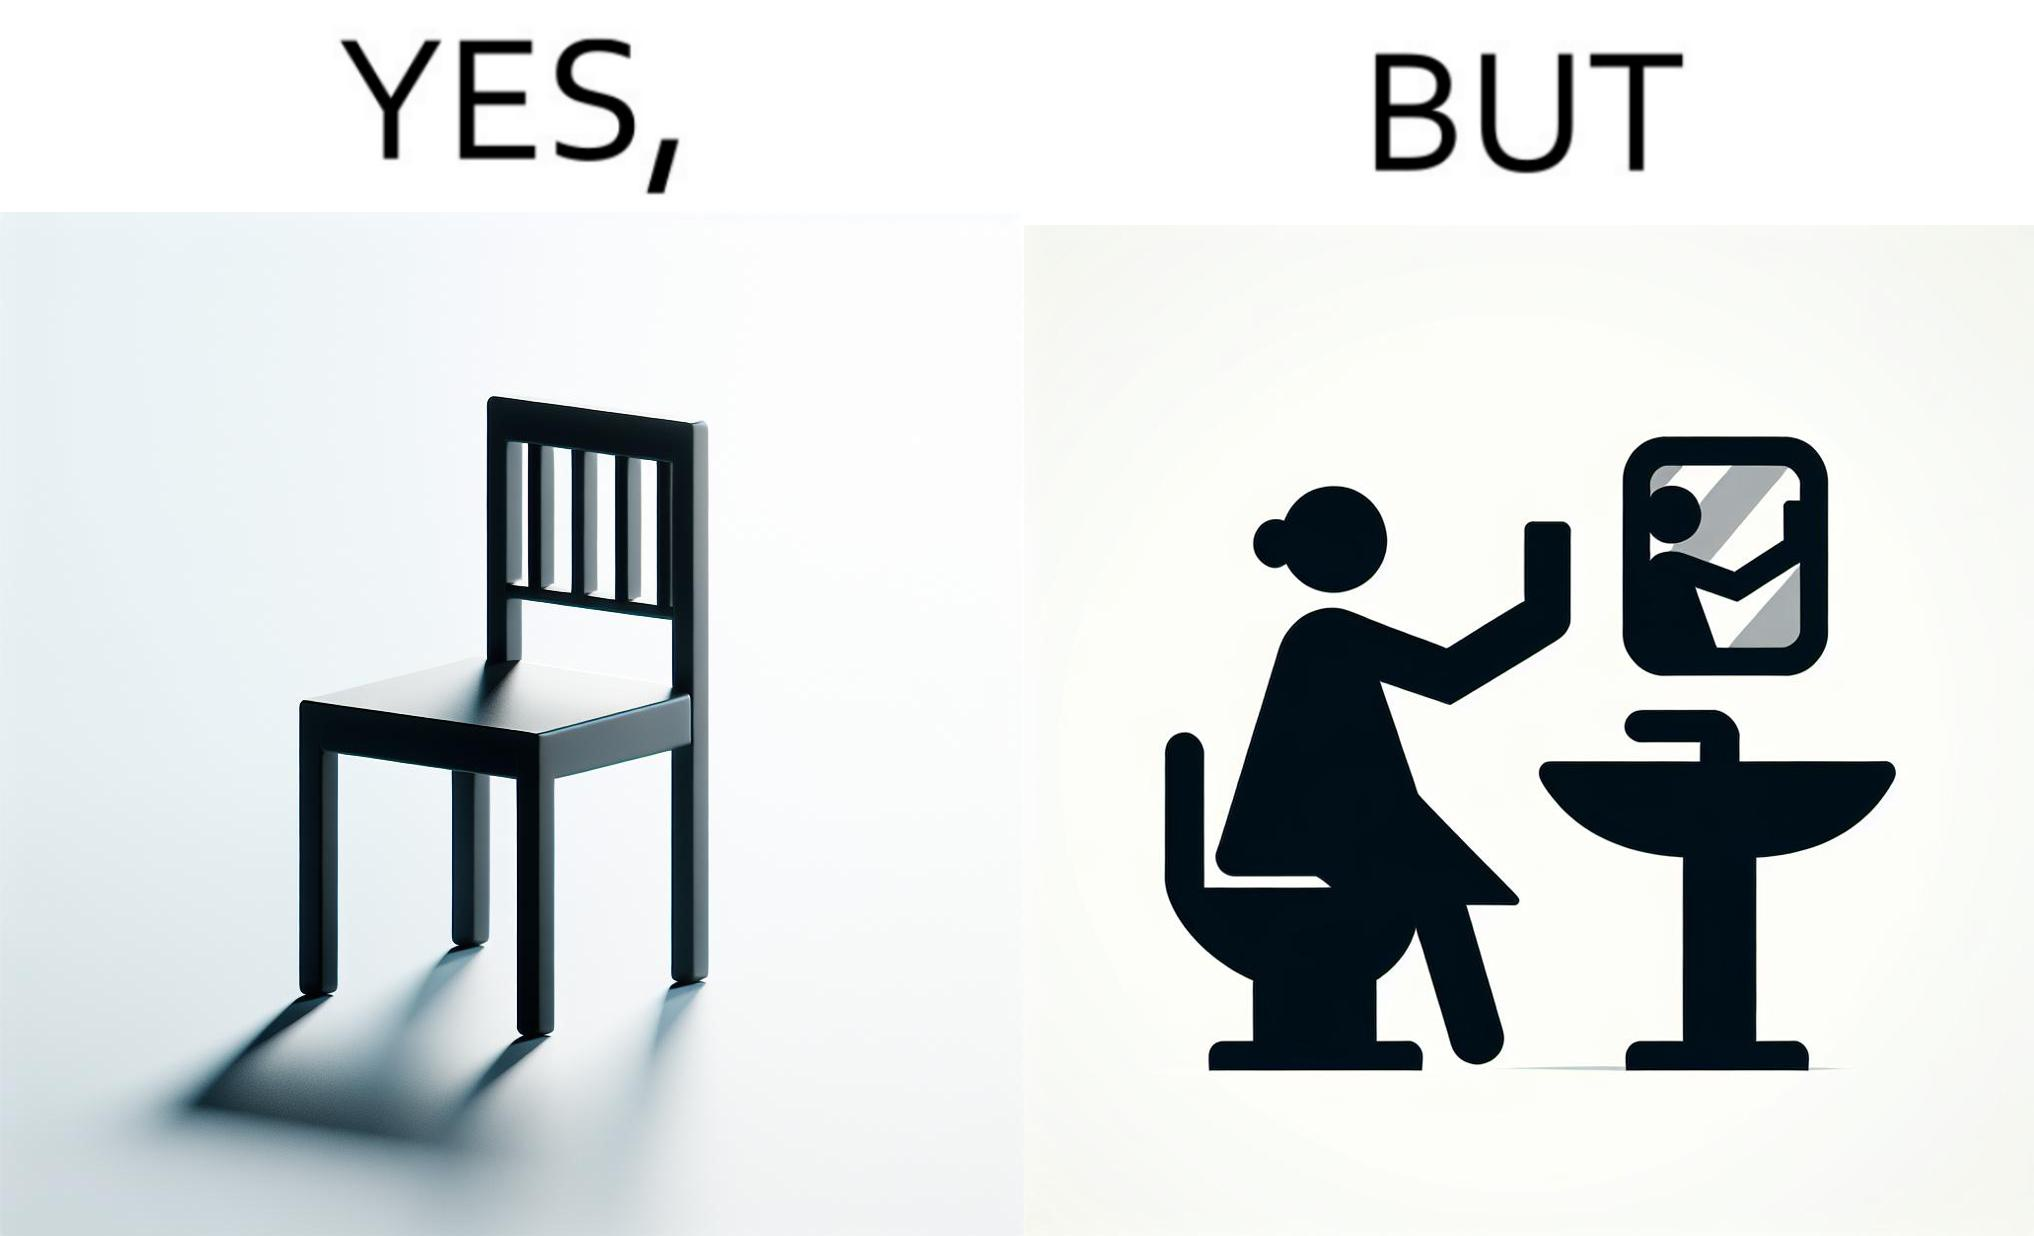Describe the content of this image. The image is ironical, as a woman is sitting by the sink taking a selfie using a mirror, while not using a chair that is actually meant for sitting. 